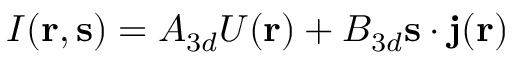Convert formula to latex. <formula><loc_0><loc_0><loc_500><loc_500>I ( { r } , { s } ) = A _ { 3 d } U ( { r } ) + B _ { 3 d } { s } \cdot { j } ( { r } )</formula> 